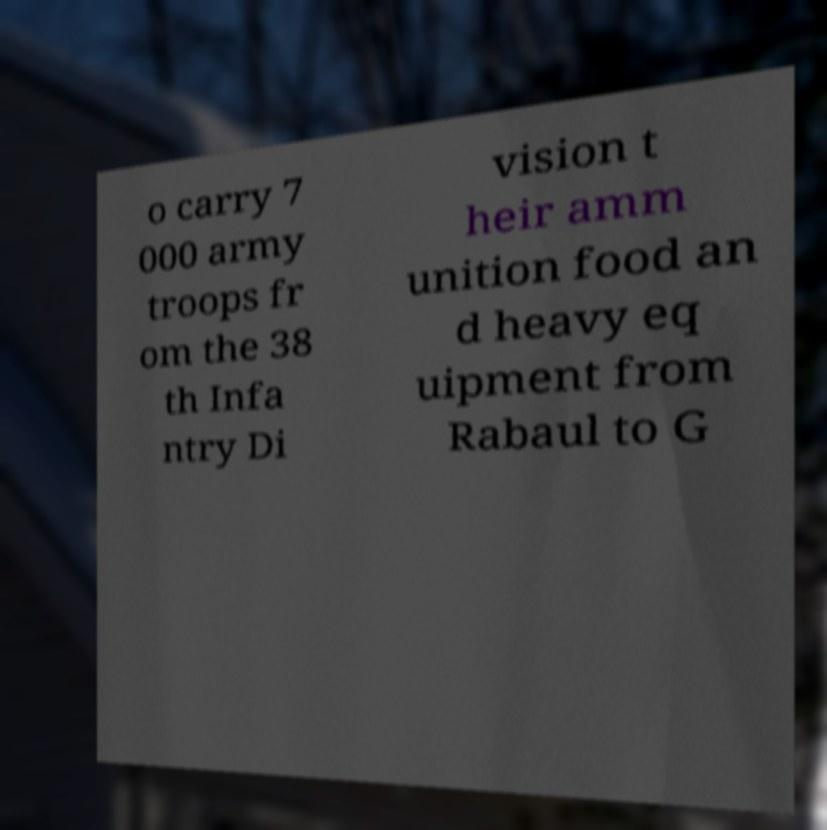Can you read and provide the text displayed in the image?This photo seems to have some interesting text. Can you extract and type it out for me? o carry 7 000 army troops fr om the 38 th Infa ntry Di vision t heir amm unition food an d heavy eq uipment from Rabaul to G 